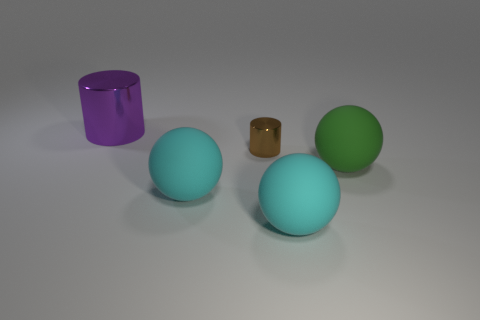Subtract all cyan matte balls. How many balls are left? 1 Add 1 green metallic spheres. How many objects exist? 6 Subtract all cylinders. How many objects are left? 3 Subtract all yellow cylinders. How many cyan spheres are left? 2 Subtract all purple cylinders. How many cylinders are left? 1 Subtract 2 cylinders. How many cylinders are left? 0 Subtract 0 yellow cubes. How many objects are left? 5 Subtract all yellow cylinders. Subtract all red balls. How many cylinders are left? 2 Subtract all tiny cyan metallic cylinders. Subtract all tiny metal cylinders. How many objects are left? 4 Add 3 purple metal objects. How many purple metal objects are left? 4 